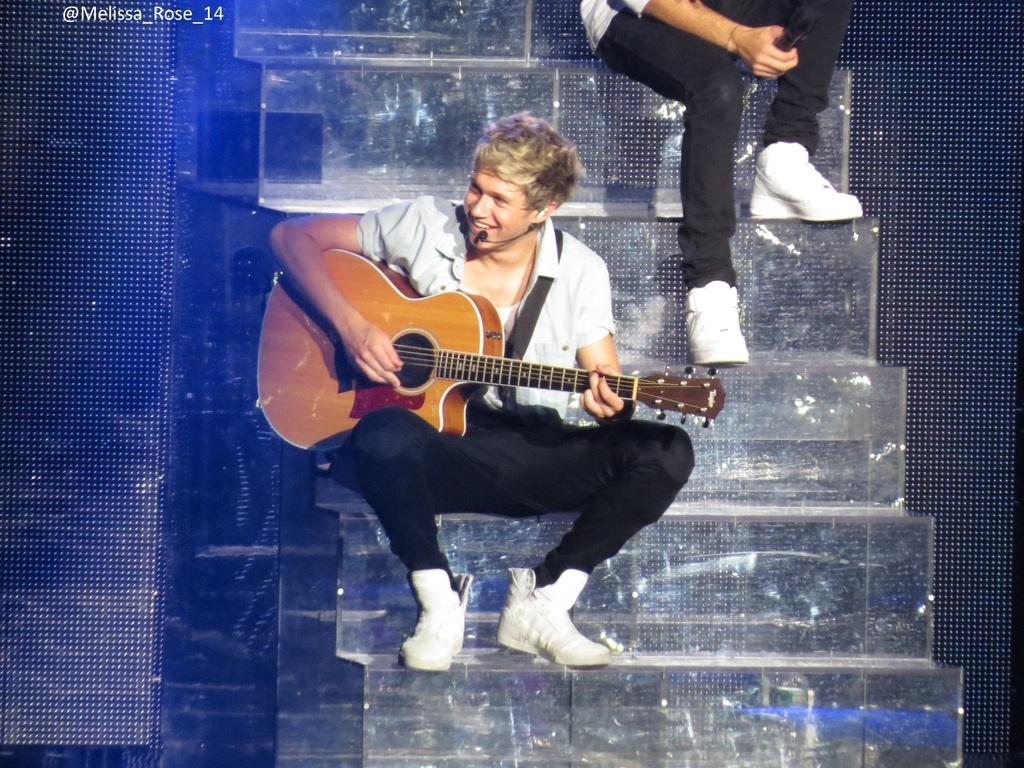Who is the main subject in the image? The main subject in the image is a boy. What is the boy doing in the image? The boy is sitting on stairs, playing a guitar, and singing into a microphone. Can you describe the setting of the image? The boy is sitting on stairs, which suggests that the image might have been taken in a stairwell or outdoor area with stairs. Are there any other people visible in the image? Yes, there is another person's legs visible in the image. What type of story is the boy telling in the image? There is no indication in the image that the boy is telling a story; he is playing a guitar and singing into a microphone. 